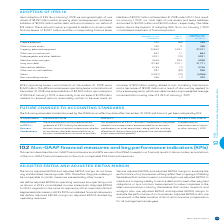According to Bce's financial document, What is the amount of right-of-use assets recognized for property, plant and equipment under the adoption of IFRS 16 in 2019? According to the financial document, $2,257 million. The relevant text states: "uary 1, 2019, we recognized right-of-use assets of $2,257 million within property, plant and equipment, and lease liabilities of $2,304 million within debt, with an i..." Also, What are the prepaid expenses in 2019 upon adoption of IFRS 16? According to the financial document, 189 (in millions). The relevant text states: "Prepaid expenses 244 (55) 189..." Also, What is the weighted average incremental borrowing rate used to discount future lease payments? According to the financial document, 3.49%. The relevant text states: "g a weighted average incremental borrowing rate of 3.49% at January 1, 2019...." Also, can you calculate: What is the total change between December 31, 2018 to January 1, 2019 due to the adoption of IFRS 16? Based on the calculation: -55+9+2,257+17-10+293+2,011-7-39-19-1, the result is 4456 (in millions). This is based on the information: "Property, plant and equipment 24,844 2,257 27,101 Prepaid expenses 244 (55) 189 Property, plant and equipment 24,844 2,257 27,101 Property, plant and equipment 24,844 2,257 27,101 DECEMBER 31, 2018 AS..." The key data points involved are: 1, 10, 17. Also, can you calculate: What is the percentage change in other current assets due to the adoption of IFRS 16? To answer this question, I need to perform calculations using the financial data. The calculation is: (338-329)/329, which equals 2.74 (percentage). This is based on the information: "Other current assets 329 9 338 Other current assets 329 9 338..." The key data points involved are: 329, 338. Also, can you calculate: What is the percentage change in Debt due within one year due to the adoption of IFRS 16? To answer this question, I need to perform calculations using the financial data. The calculation is: (4,938-4,645)/4,645, which equals 6.31 (percentage). This is based on the information: "Debt due within one year 4,645 293 4,938 Debt due within one year 4,645 293 4,938..." The key data points involved are: 4,645, 4,938. 